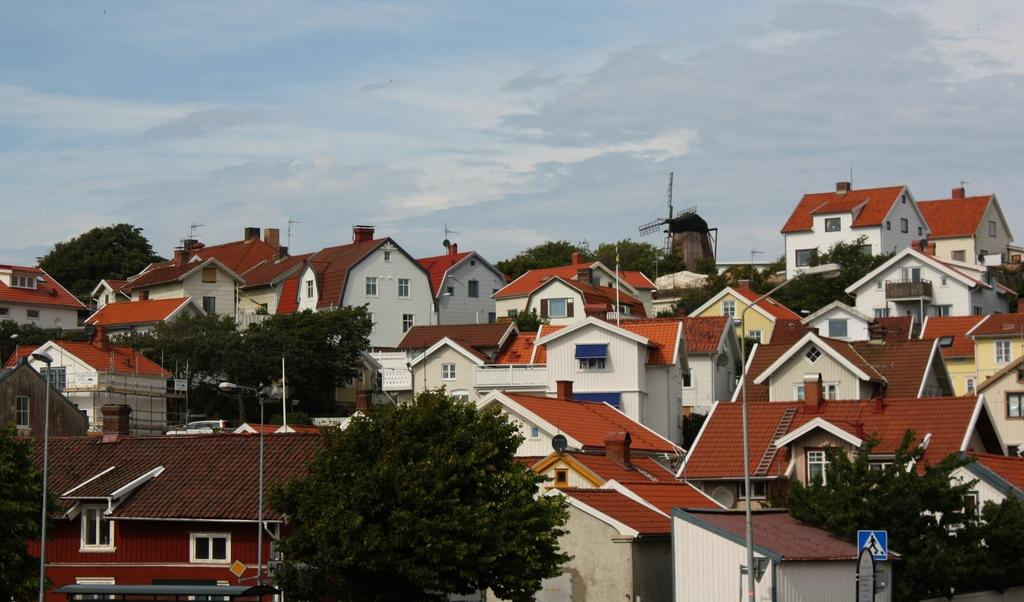What type of natural elements can be seen in the image? There are trees in the image. What man-made structures are present in the image? There are poles, a signboard, a ladder, and buildings with windows in the image. Can you describe the unspecified objects in the image? Unfortunately, the facts provided do not specify the nature of these objects. What is visible in the background of the image? The sky is visible in the background of the image. What type of vegetable is growing on the trees in the image? There is no vegetable growing on the trees in the image; the trees are not specified as fruit-bearing or vegetable-producing. Can you see any geese flying in the sky in the image? There is no mention of geese or any flying creatures in the image; only trees, poles, a signboard, a ladder, buildings, unspecified objects, and the sky are mentioned. 